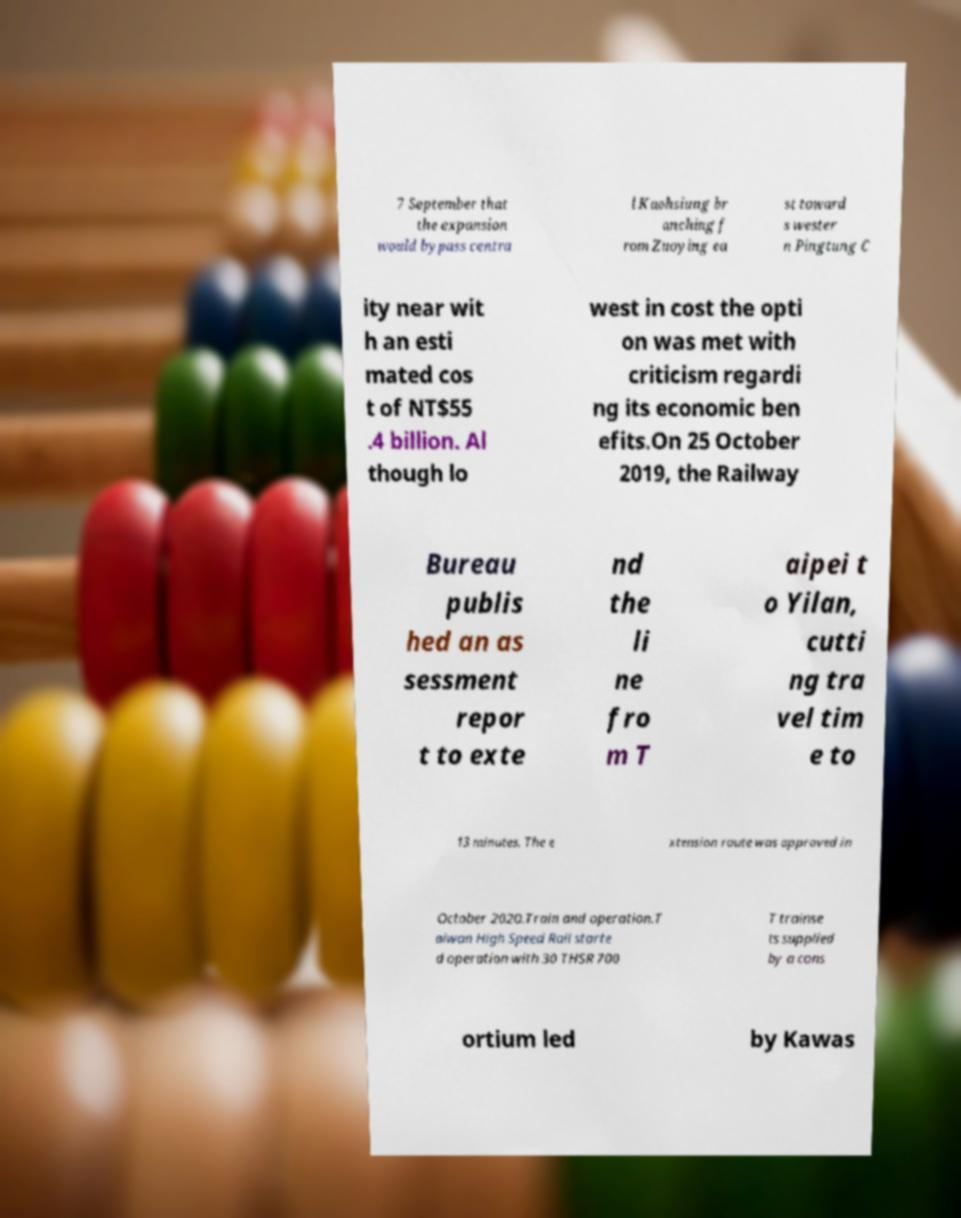For documentation purposes, I need the text within this image transcribed. Could you provide that? 7 September that the expansion would bypass centra l Kaohsiung br anching f rom Zuoying ea st toward s wester n Pingtung C ity near wit h an esti mated cos t of NT$55 .4 billion. Al though lo west in cost the opti on was met with criticism regardi ng its economic ben efits.On 25 October 2019, the Railway Bureau publis hed an as sessment repor t to exte nd the li ne fro m T aipei t o Yilan, cutti ng tra vel tim e to 13 minutes. The e xtension route was approved in October 2020.Train and operation.T aiwan High Speed Rail starte d operation with 30 THSR 700 T trainse ts supplied by a cons ortium led by Kawas 